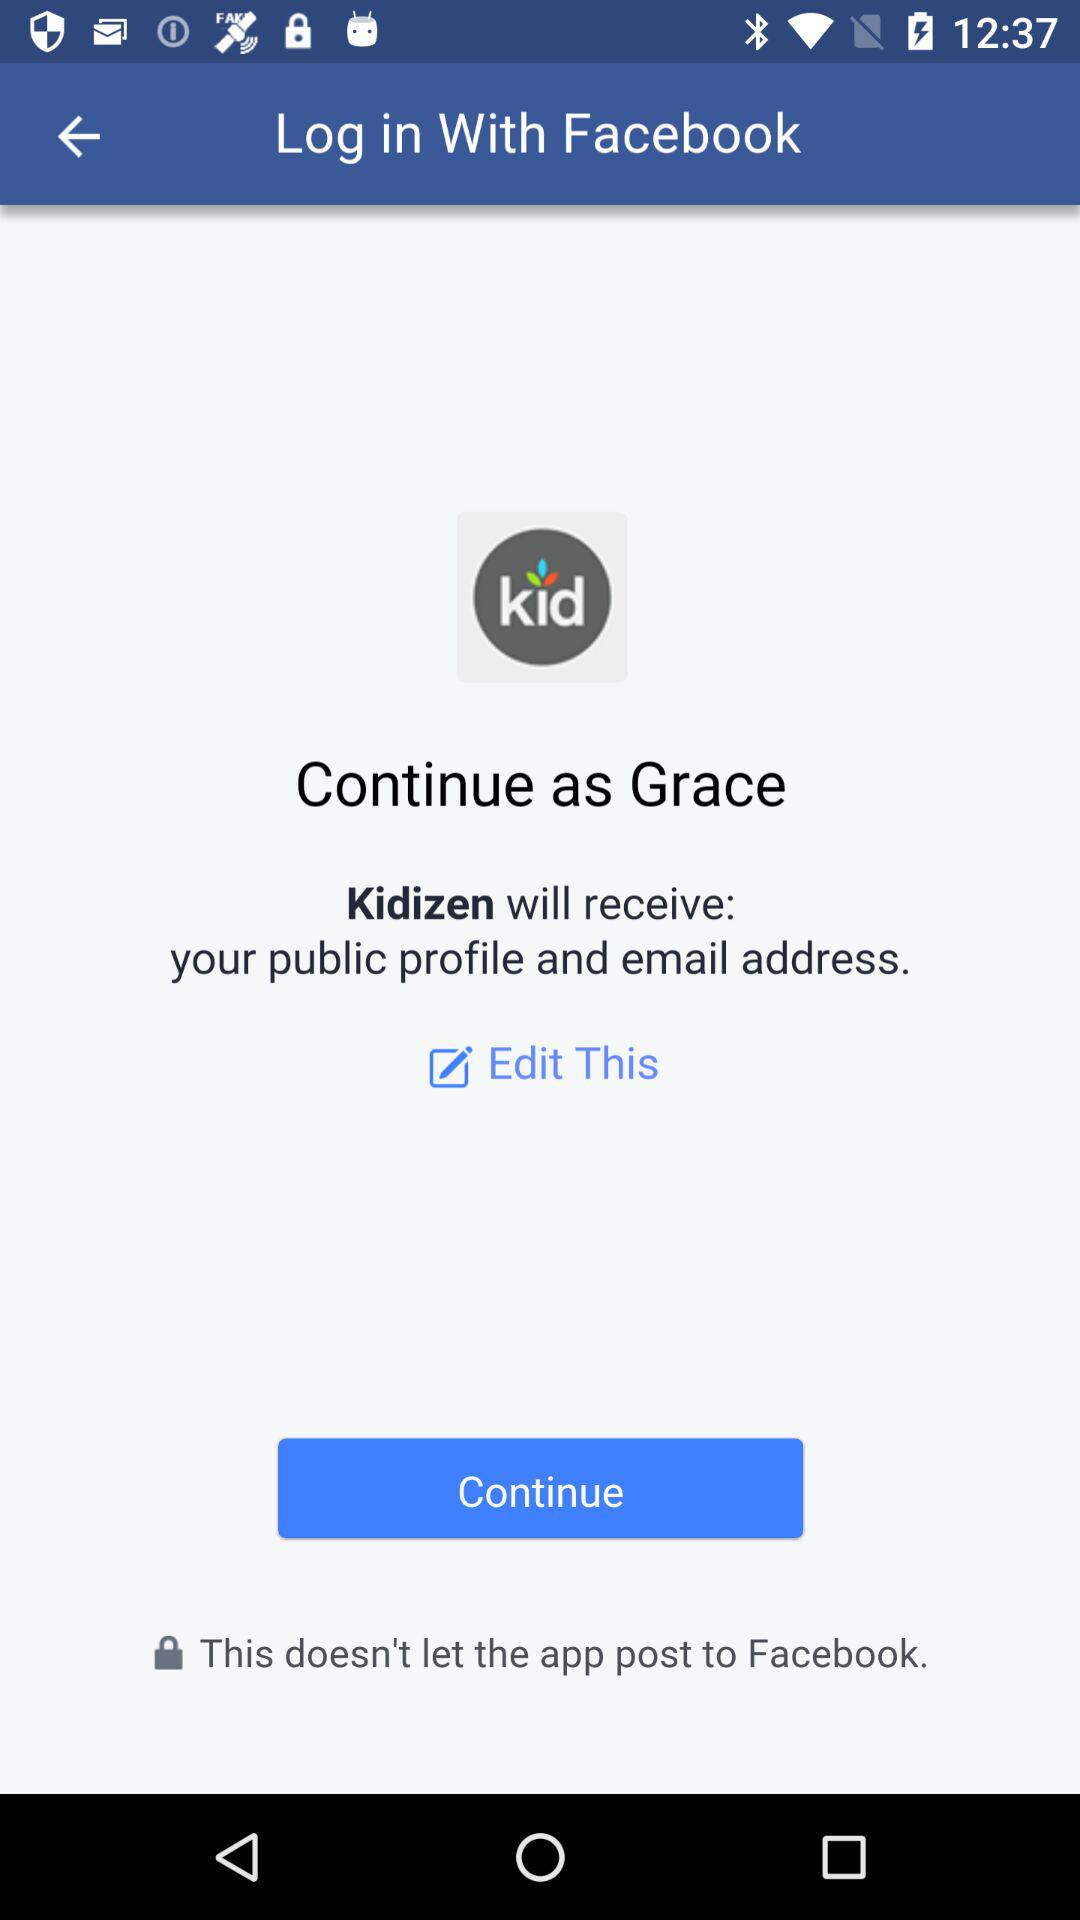What application will receive the public profile and email address? The application that will receive the public profile and email address is "Kidizen". 